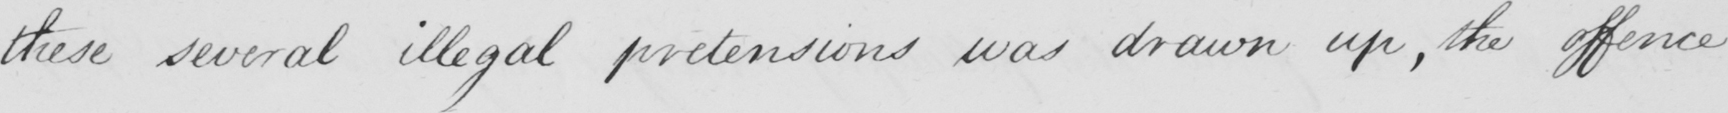What is written in this line of handwriting? these several illegal pretensions was drawn up , the offence 